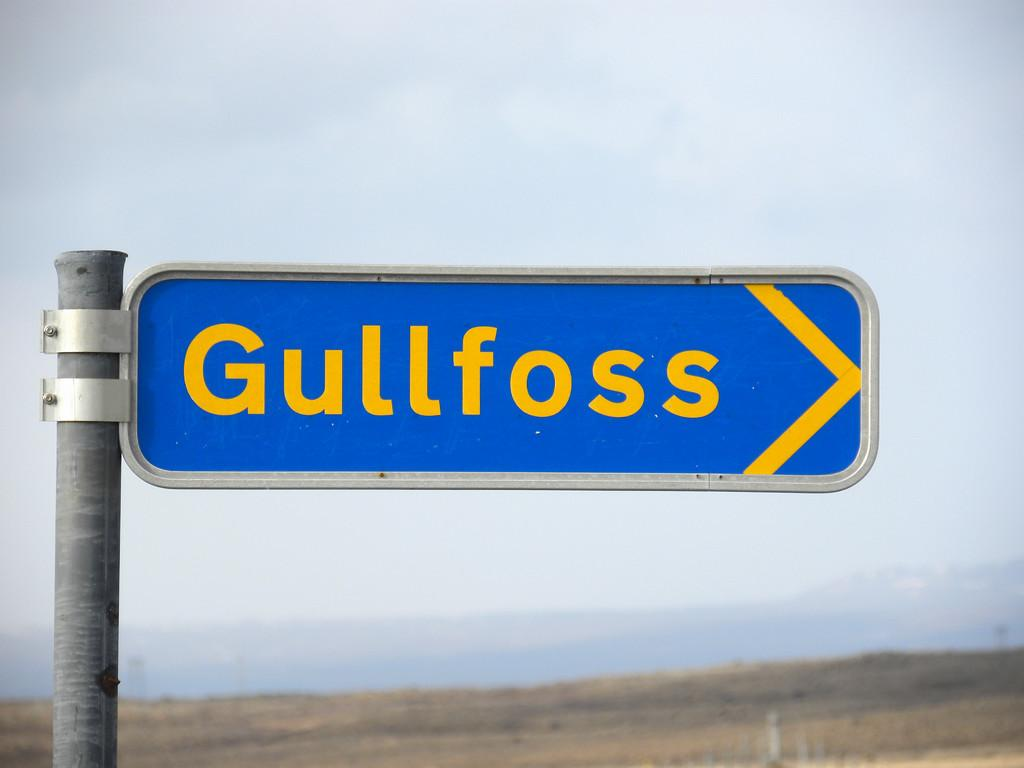Provide a one-sentence caption for the provided image. A blue road sign for the area of Gullfoss. 